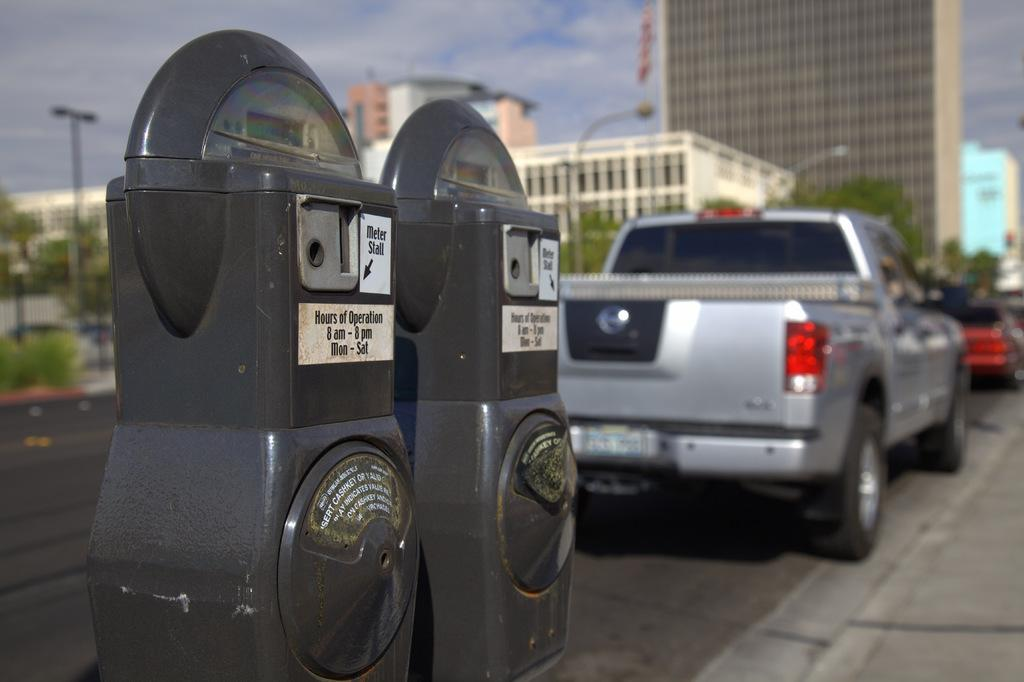<image>
Provide a brief description of the given image. a parking meter with the word stall on the front 